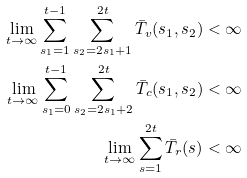Convert formula to latex. <formula><loc_0><loc_0><loc_500><loc_500>\lim _ { t \to \infty } \sum _ { s _ { 1 } = 1 } ^ { t - 1 } \sum _ { s _ { 2 } = 2 s _ { 1 } + 1 } ^ { 2 t } \bar { T } _ { v } ( s _ { 1 } , s _ { 2 } ) < \infty \\ \lim _ { t \to \infty } \sum _ { s _ { 1 } = 0 } ^ { t - 1 } \sum _ { s _ { 2 } = 2 s _ { 1 } + 2 } ^ { 2 t } \bar { T } _ { c } ( s _ { 1 } , s _ { 2 } ) < \infty \\ \lim _ { t \to \infty } \sum _ { s = 1 } ^ { 2 t } \bar { T } _ { r } ( s ) < \infty</formula> 